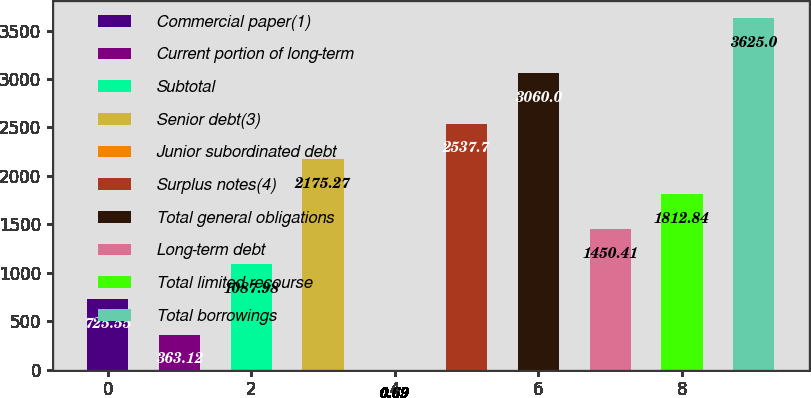<chart> <loc_0><loc_0><loc_500><loc_500><bar_chart><fcel>Commercial paper(1)<fcel>Current portion of long-term<fcel>Subtotal<fcel>Senior debt(3)<fcel>Junior subordinated debt<fcel>Surplus notes(4)<fcel>Total general obligations<fcel>Long-term debt<fcel>Total limited recourse<fcel>Total borrowings<nl><fcel>725.55<fcel>363.12<fcel>1087.98<fcel>2175.27<fcel>0.69<fcel>2537.7<fcel>3060<fcel>1450.41<fcel>1812.84<fcel>3625<nl></chart> 